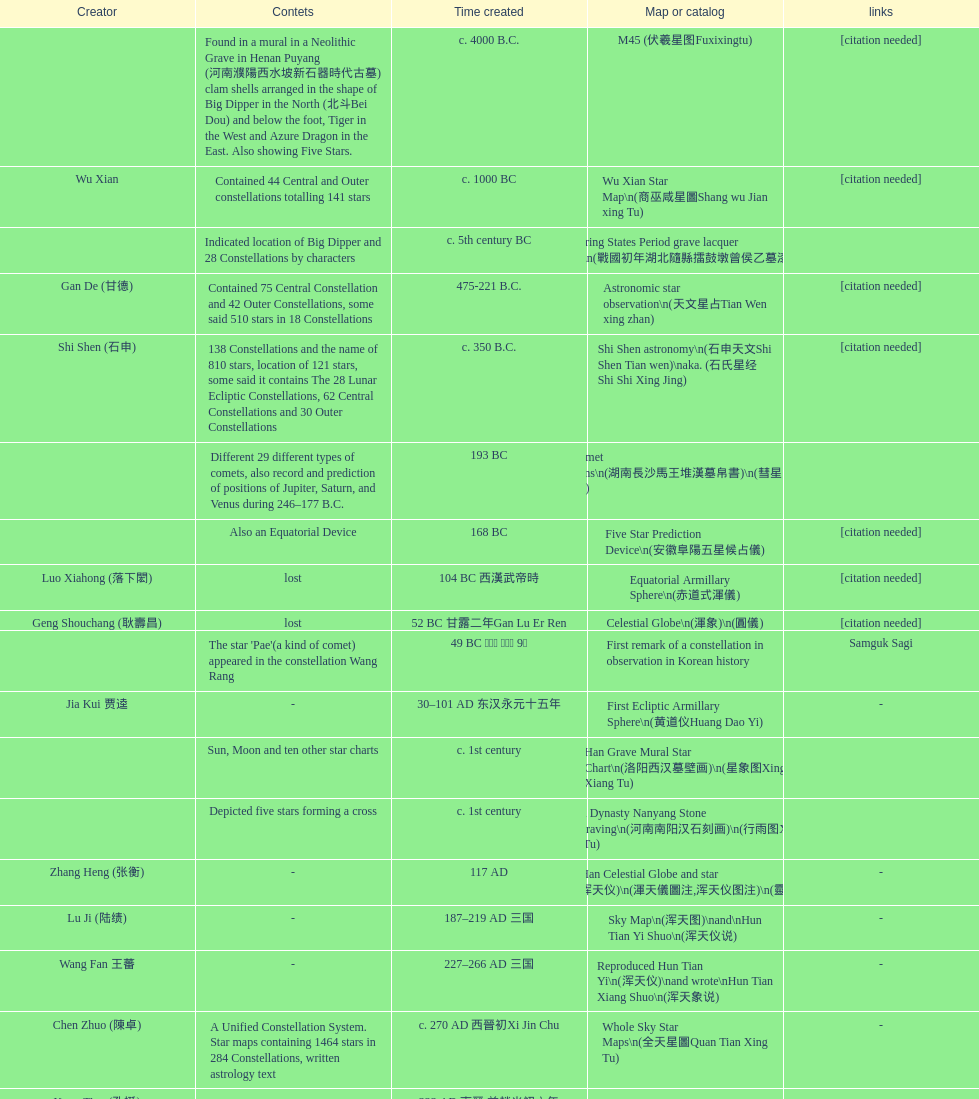What is the name of the oldest map/catalog? M45. 